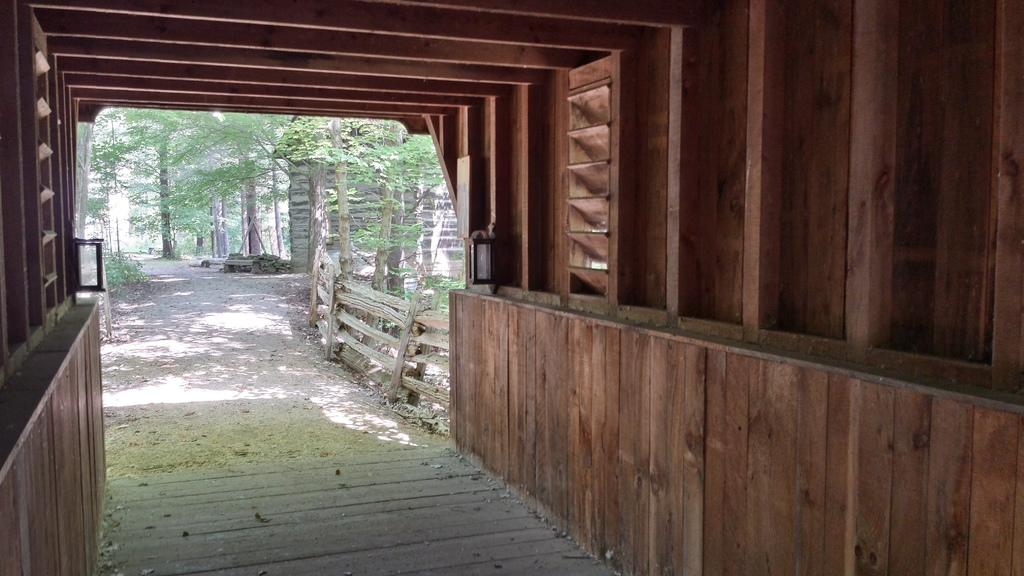What type of structure is visible in the image? There is a garage in the image. What type of barrier surrounds the property in the image? There is a wooden fence in the image. What type of vegetation can be seen in the image? There are trees and plants in the image. What type of education can be seen being offered in the image? There is no indication of education being offered in the image. 